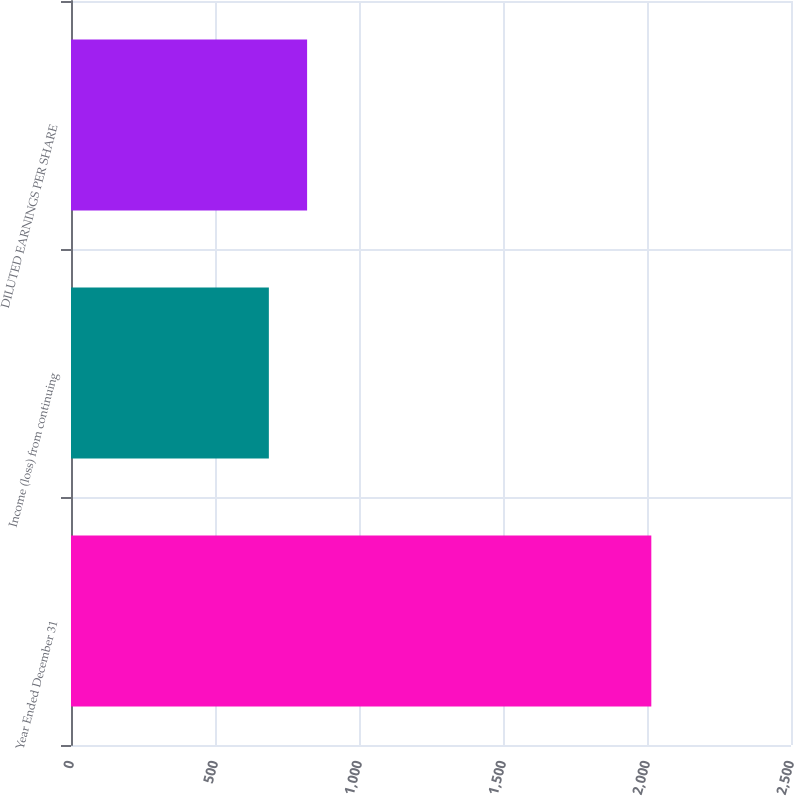<chart> <loc_0><loc_0><loc_500><loc_500><bar_chart><fcel>Year Ended December 31<fcel>Income (loss) from continuing<fcel>DILUTED EARNINGS PER SHARE<nl><fcel>2015<fcel>687<fcel>819.8<nl></chart> 